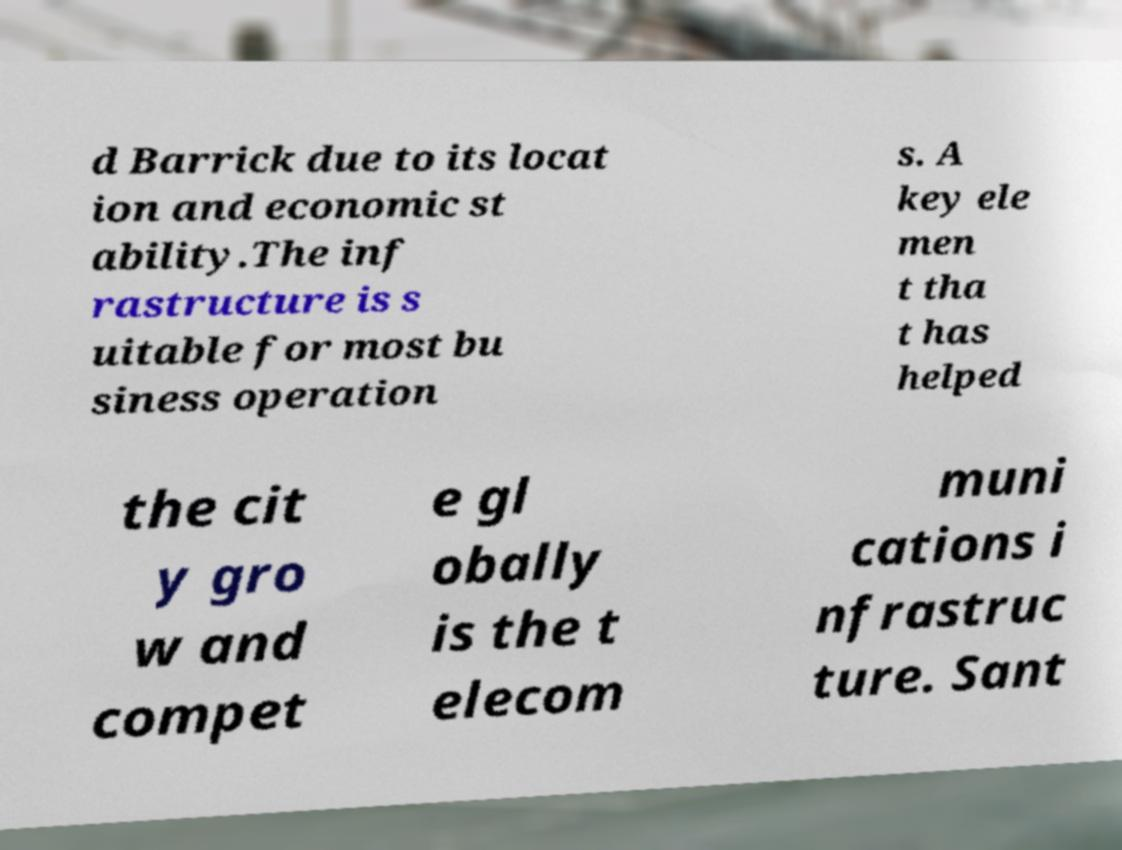Can you read and provide the text displayed in the image?This photo seems to have some interesting text. Can you extract and type it out for me? d Barrick due to its locat ion and economic st ability.The inf rastructure is s uitable for most bu siness operation s. A key ele men t tha t has helped the cit y gro w and compet e gl obally is the t elecom muni cations i nfrastruc ture. Sant 